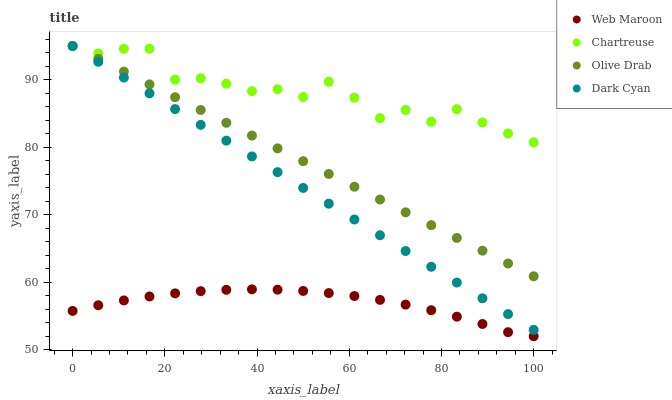Does Web Maroon have the minimum area under the curve?
Answer yes or no. Yes. Does Chartreuse have the maximum area under the curve?
Answer yes or no. Yes. Does Chartreuse have the minimum area under the curve?
Answer yes or no. No. Does Web Maroon have the maximum area under the curve?
Answer yes or no. No. Is Olive Drab the smoothest?
Answer yes or no. Yes. Is Chartreuse the roughest?
Answer yes or no. Yes. Is Web Maroon the smoothest?
Answer yes or no. No. Is Web Maroon the roughest?
Answer yes or no. No. Does Web Maroon have the lowest value?
Answer yes or no. Yes. Does Chartreuse have the lowest value?
Answer yes or no. No. Does Olive Drab have the highest value?
Answer yes or no. Yes. Does Web Maroon have the highest value?
Answer yes or no. No. Is Web Maroon less than Olive Drab?
Answer yes or no. Yes. Is Dark Cyan greater than Web Maroon?
Answer yes or no. Yes. Does Chartreuse intersect Dark Cyan?
Answer yes or no. Yes. Is Chartreuse less than Dark Cyan?
Answer yes or no. No. Is Chartreuse greater than Dark Cyan?
Answer yes or no. No. Does Web Maroon intersect Olive Drab?
Answer yes or no. No. 